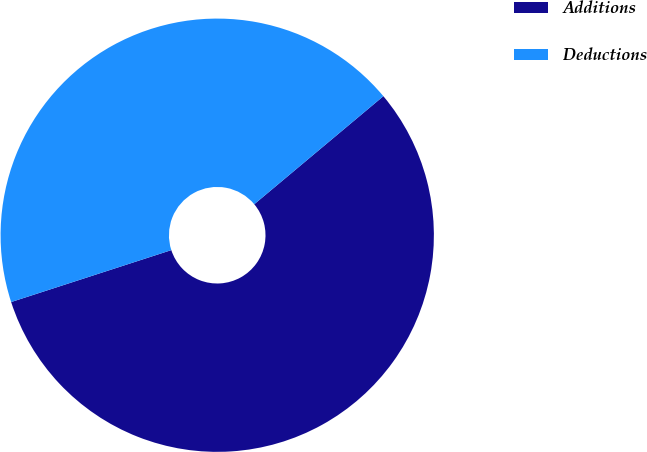Convert chart. <chart><loc_0><loc_0><loc_500><loc_500><pie_chart><fcel>Additions<fcel>Deductions<nl><fcel>56.1%<fcel>43.9%<nl></chart> 